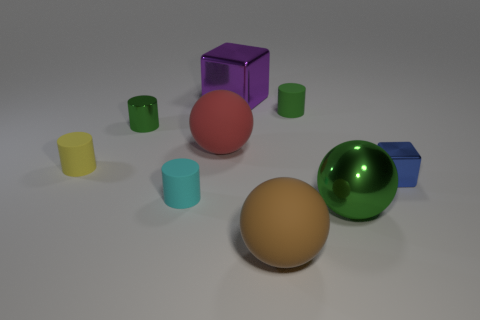How many objects are there, and can you describe their shapes? There are nine objects in total, comprising a variety of geometric shapes. Specifically, there are three spheres, a cube, four cylinders, and a rectangular prism. Which shapes are repeated and what colors are they? Spheres and cylinders are repeated shapes. There is one green, one red, and one brown sphere. As for the cylinders, one is yellow, one is light blue, and two are smaller green cylinders. 